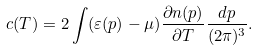<formula> <loc_0><loc_0><loc_500><loc_500>c ( T ) = 2 \int ( \varepsilon ( { p } ) - \mu ) \frac { \partial n ( { p } ) } { \partial T } \frac { d { p } } { ( 2 \pi ) ^ { 3 } } .</formula> 